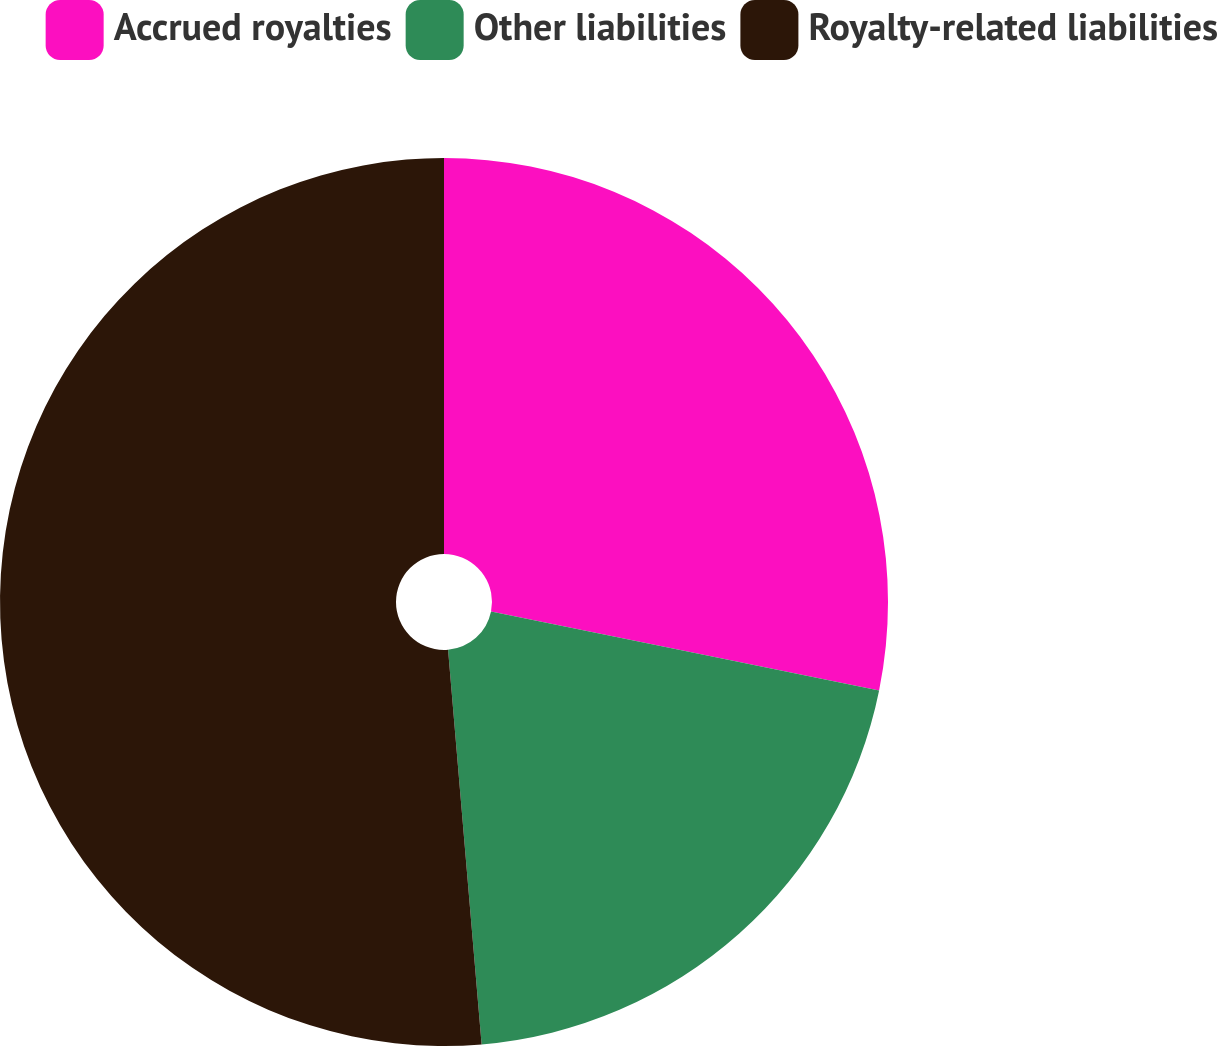Convert chart. <chart><loc_0><loc_0><loc_500><loc_500><pie_chart><fcel>Accrued royalties<fcel>Other liabilities<fcel>Royalty-related liabilities<nl><fcel>28.19%<fcel>20.46%<fcel>51.35%<nl></chart> 